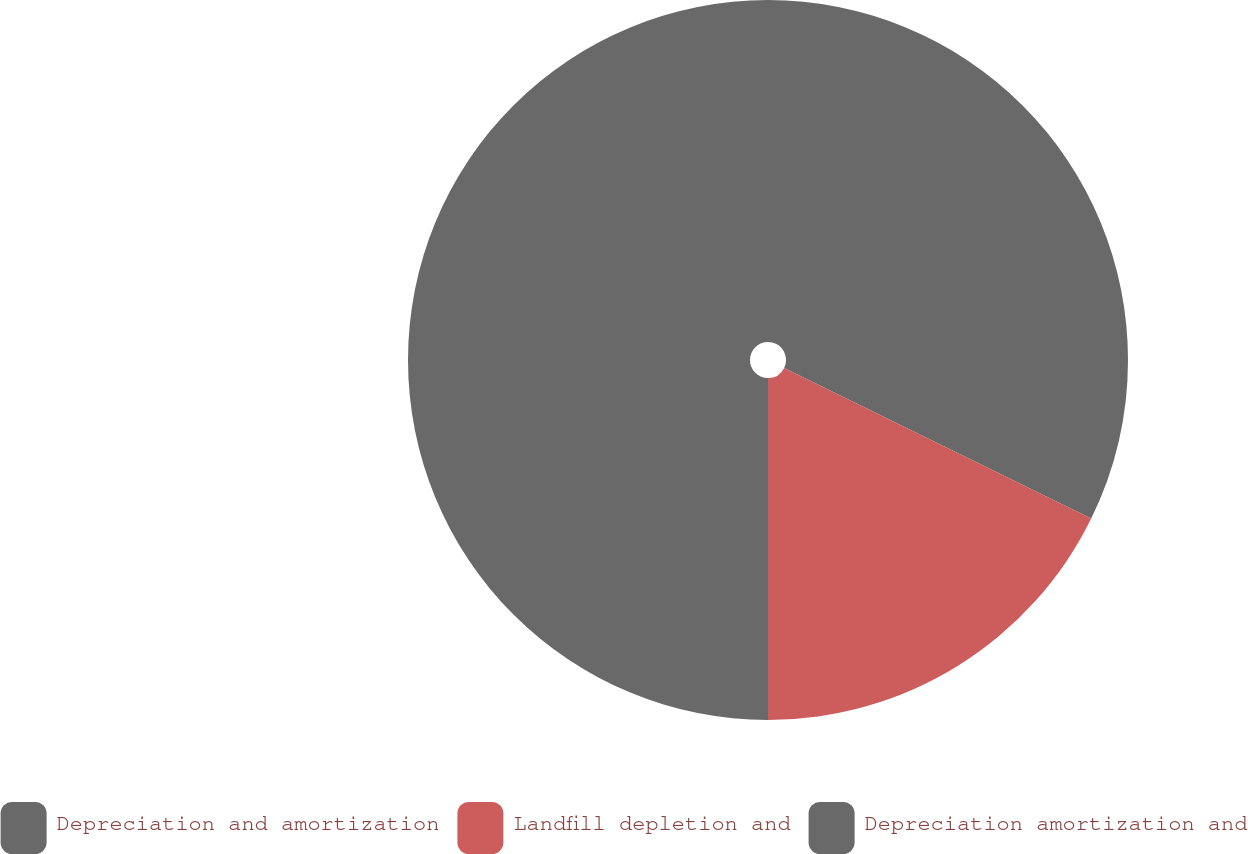<chart> <loc_0><loc_0><loc_500><loc_500><pie_chart><fcel>Depreciation and amortization<fcel>Landfill depletion and<fcel>Depreciation amortization and<nl><fcel>32.26%<fcel>17.74%<fcel>50.0%<nl></chart> 